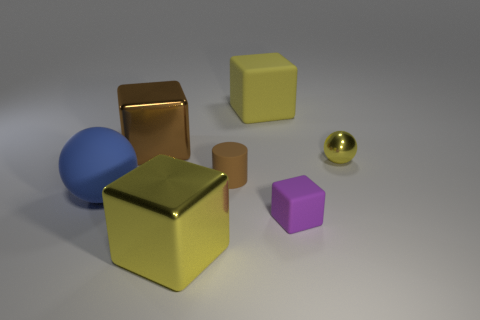Can you describe the different textures visible in this image? Certainly, the image showcases a variety of textures. The large yellow block has a matte, slightly rough texture that diffuses light. In contrast, the small gold-colored ball and the large copper-colored cube exhibit a smooth, reflective surface that suggests a metallic texture. The blue spherical object has a diffuse reflection, which might indicate a plastic or painted wood material, while the purple cube appears to have a slightly reflective, smooth surface akin to a matte finish on metal or plastic.  What can you infer about the blue and purple objects' materials compared to the gold-colored ones? The blue and purple objects have less reflectivity and a matte surface compared to the gold-colored objects. This indicates that the blue and purple objects are likely made of a non-metallic material, such as plastic or matte-finished painted surfaces, which typically have a more diffuse reflection and absorb more light. The gold-colored objects, on the other hand, have a high level of reflectivity and a polished finish, suggesting they are likely metallic. 